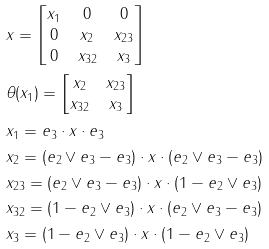Convert formula to latex. <formula><loc_0><loc_0><loc_500><loc_500>& x = \begin{bmatrix} x _ { 1 } & 0 & 0 \\ 0 & x _ { 2 } & x _ { 2 3 } \\ 0 & x _ { 3 2 } & x _ { 3 } \end{bmatrix} \\ & \theta ( x _ { 1 } ) = \begin{bmatrix} x _ { 2 } & x _ { 2 3 } \\ x _ { 3 2 } & x _ { 3 } \end{bmatrix} \\ & x _ { 1 } = e _ { 3 } \cdot x \cdot e _ { 3 } \\ & x _ { 2 } = ( e _ { 2 } \vee e _ { 3 } - e _ { 3 } ) \cdot x \cdot ( e _ { 2 } \vee e _ { 3 } - e _ { 3 } ) \\ & x _ { 2 3 } = ( e _ { 2 } \vee e _ { 3 } - e _ { 3 } ) \cdot x \cdot ( 1 - e _ { 2 } \vee e _ { 3 } ) \\ & x _ { 3 2 } = ( 1 - e _ { 2 } \vee e _ { 3 } ) \cdot x \cdot ( e _ { 2 } \vee e _ { 3 } - e _ { 3 } ) \\ & x _ { 3 } = ( 1 - e _ { 2 } \vee e _ { 3 } ) \cdot x \cdot ( 1 - e _ { 2 } \vee e _ { 3 } )</formula> 